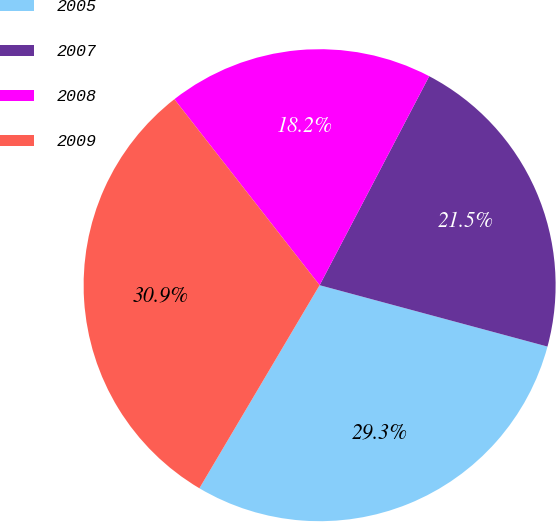Convert chart. <chart><loc_0><loc_0><loc_500><loc_500><pie_chart><fcel>2005<fcel>2007<fcel>2008<fcel>2009<nl><fcel>29.32%<fcel>21.5%<fcel>18.24%<fcel>30.94%<nl></chart> 